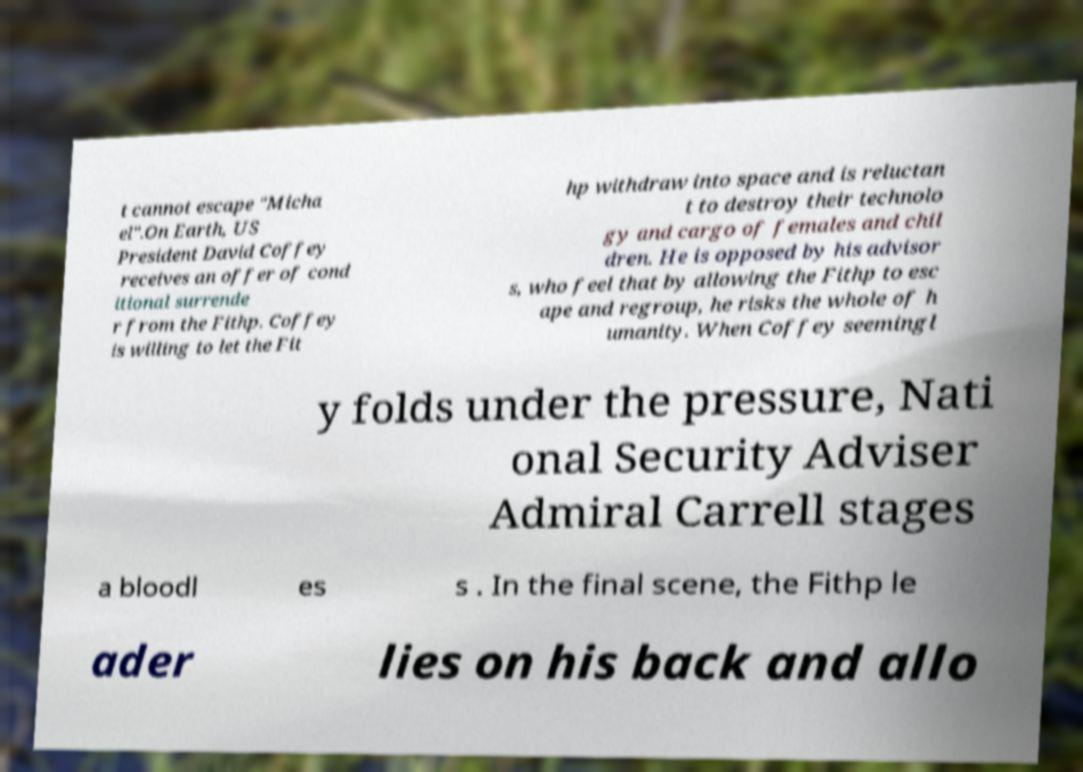Please read and relay the text visible in this image. What does it say? t cannot escape "Micha el".On Earth, US President David Coffey receives an offer of cond itional surrende r from the Fithp. Coffey is willing to let the Fit hp withdraw into space and is reluctan t to destroy their technolo gy and cargo of females and chil dren. He is opposed by his advisor s, who feel that by allowing the Fithp to esc ape and regroup, he risks the whole of h umanity. When Coffey seemingl y folds under the pressure, Nati onal Security Adviser Admiral Carrell stages a bloodl es s . In the final scene, the Fithp le ader lies on his back and allo 